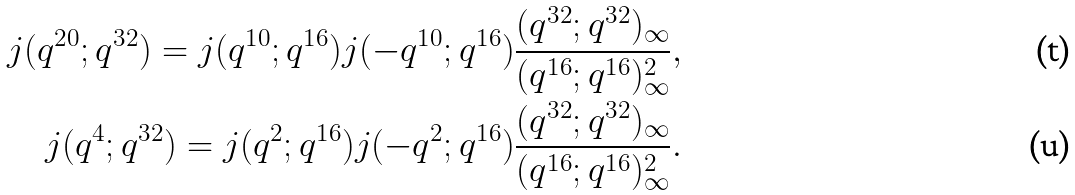<formula> <loc_0><loc_0><loc_500><loc_500>j ( q ^ { 2 0 } ; q ^ { 3 2 } ) = j ( q ^ { 1 0 } ; q ^ { 1 6 } ) j ( - q ^ { 1 0 } ; q ^ { 1 6 } ) \frac { ( q ^ { 3 2 } ; q ^ { 3 2 } ) _ { \infty } } { ( q ^ { 1 6 } ; q ^ { 1 6 } ) _ { \infty } ^ { 2 } } , \\ j ( q ^ { 4 } ; q ^ { 3 2 } ) = j ( q ^ { 2 } ; q ^ { 1 6 } ) j ( - q ^ { 2 } ; q ^ { 1 6 } ) \frac { ( q ^ { 3 2 } ; q ^ { 3 2 } ) _ { \infty } } { ( q ^ { 1 6 } ; q ^ { 1 6 } ) _ { \infty } ^ { 2 } } .</formula> 